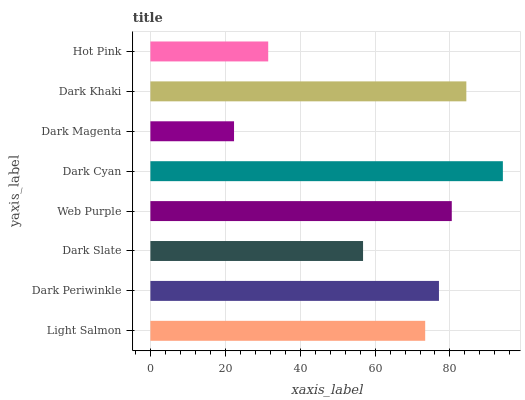Is Dark Magenta the minimum?
Answer yes or no. Yes. Is Dark Cyan the maximum?
Answer yes or no. Yes. Is Dark Periwinkle the minimum?
Answer yes or no. No. Is Dark Periwinkle the maximum?
Answer yes or no. No. Is Dark Periwinkle greater than Light Salmon?
Answer yes or no. Yes. Is Light Salmon less than Dark Periwinkle?
Answer yes or no. Yes. Is Light Salmon greater than Dark Periwinkle?
Answer yes or no. No. Is Dark Periwinkle less than Light Salmon?
Answer yes or no. No. Is Dark Periwinkle the high median?
Answer yes or no. Yes. Is Light Salmon the low median?
Answer yes or no. Yes. Is Dark Khaki the high median?
Answer yes or no. No. Is Dark Slate the low median?
Answer yes or no. No. 